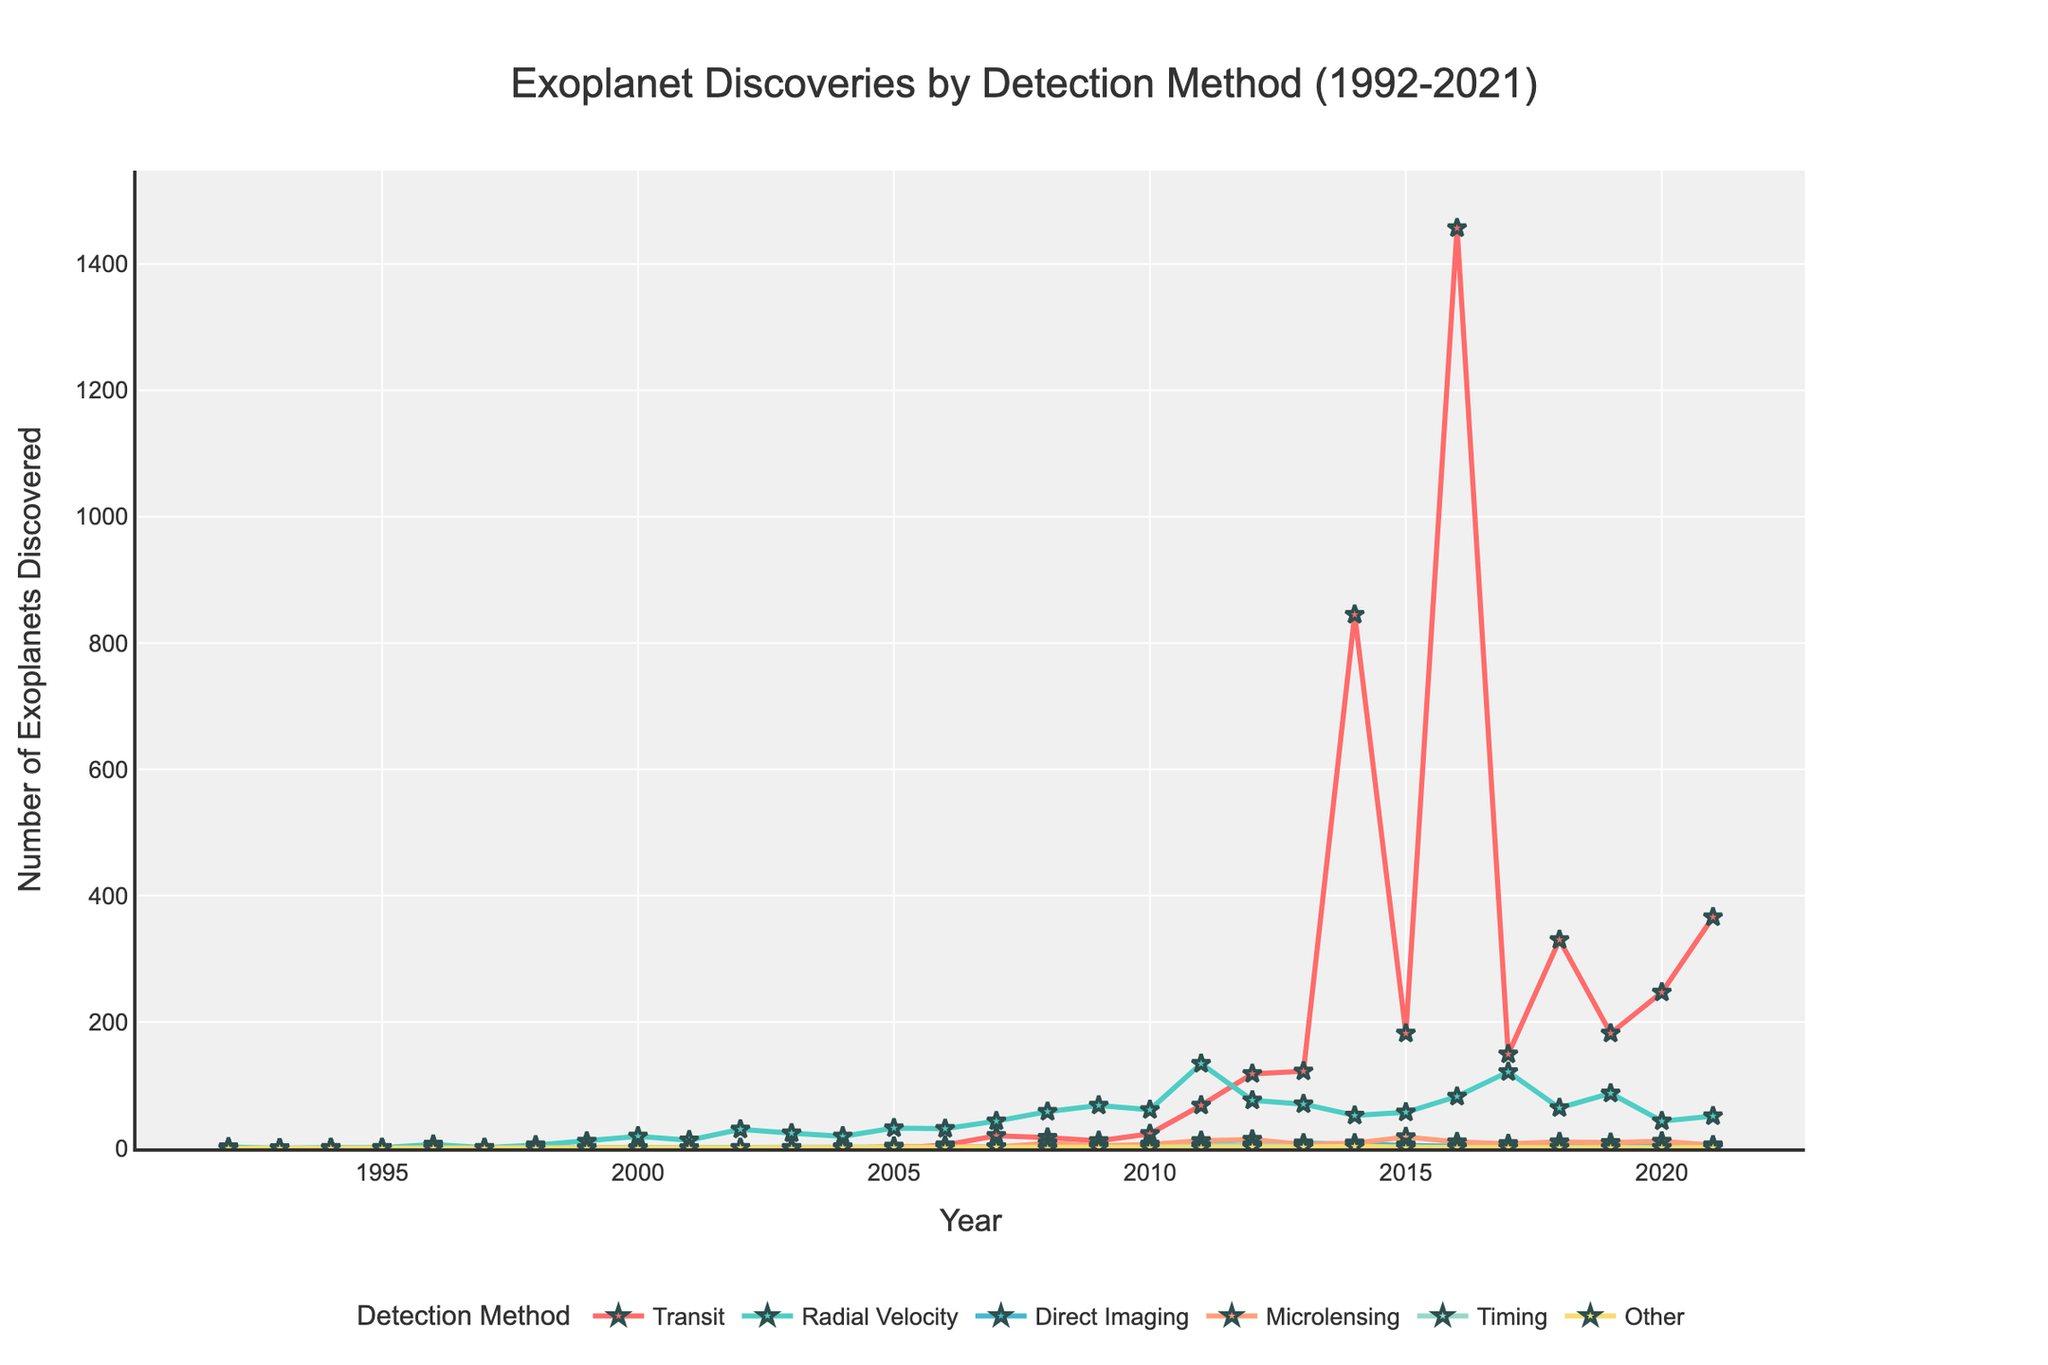What year saw the highest number of exoplanets discovered using the Transit method? The line corresponding to the Transit method peaks in 2016. This can be observed as the highest point on the plot for the red line (Transit).
Answer: 2016 Which year had the greatest total number of exoplanets discovered across all methods combined? By observing the height of all lines combined, 2016 stands out as the highest peak in the combined total of exoplanets discovered.
Answer: 2016 Between 2018 and 2020, how did the number of exoplanets discovered using Radial Velocity compare to those discovered using the Transit method? By counting the data points on the plot, in 2018, Transit (330) was higher than Radial Velocity (64). In 2019, Transit (182) was higher than Radial Velocity (87). In 2020, Transit (247) was higher than Radial Velocity (43).
Answer: Transit was higher each year How many more exoplanets were discovered using Transit method in 2014 compared to 2015? In 2014, 845 exoplanets were discovered using Transit, and in 2015, 182 were discovered using the same method. Subtracting these gives 845 - 182 = 663.
Answer: 663 Which detection method saw the steepest increase in number of exoplanets discovered between its lowest and highest points, and what are those numbers? The Transit method saw the steepest increase from 0 in the early 1990s to 1457 in 2016. Observing the plot, this line starts nearly at the bottom and reaches the highest peak. Radial Velocity also shows a steep increase but is less pronounced.
Answer: Transit; 0 to 1457 Over what range of years was the absolute number of exoplanets discovered using Microlensing continually increasing? Microlensing discoveries start increasing from 2004, reaching a peak in 2015. Observing the line for Microlensing (orange line), we note a continual upward trend without any dips from 2004 to 2015.
Answer: 2004-2015 In which year was the number of exoplanets discovered using Direct Imaging greater than or equal to those discovered using Timing? In 2011 and 2013, the number of exoplanets discovered using Direct Imaging (9 and 8 respectively) is greater than or equal to those using Timing (4 and 2 respectively).
Answer: 2011 and 2013 What was the first year that had more than 50 exoplanets discovered via Radial Velocity? Observing the Radial Velocity line (green line), it surpasses the 50 mark for the first time in 2007.
Answer: 2007 Is there any year where the total number of exoplanets discovered using all methods is a round number (e.g., 100, 200)? Adding the exoplanet discoveries for each method for each year, 2011 stands out with a total of 228 (68 Transit + 134 Radial Velocity + 9 Direct Imaging + 12 Microlensing + 4 Timing + 1 Other).
Answer: No 